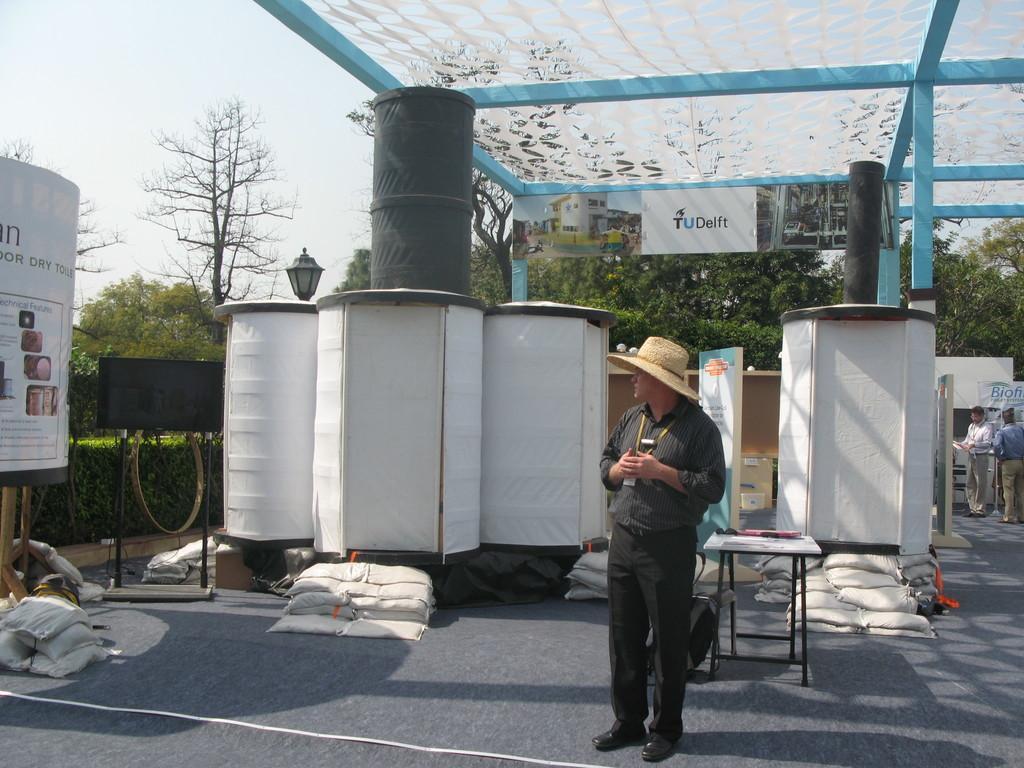In one or two sentences, can you explain what this image depicts? In this picture there is a man wearing black color shirt and cowboy cap, standing in the front and looking on the left side. Behind there are some white and black drums. On the top there is a blue color iron frame. In the background there are some trees. 